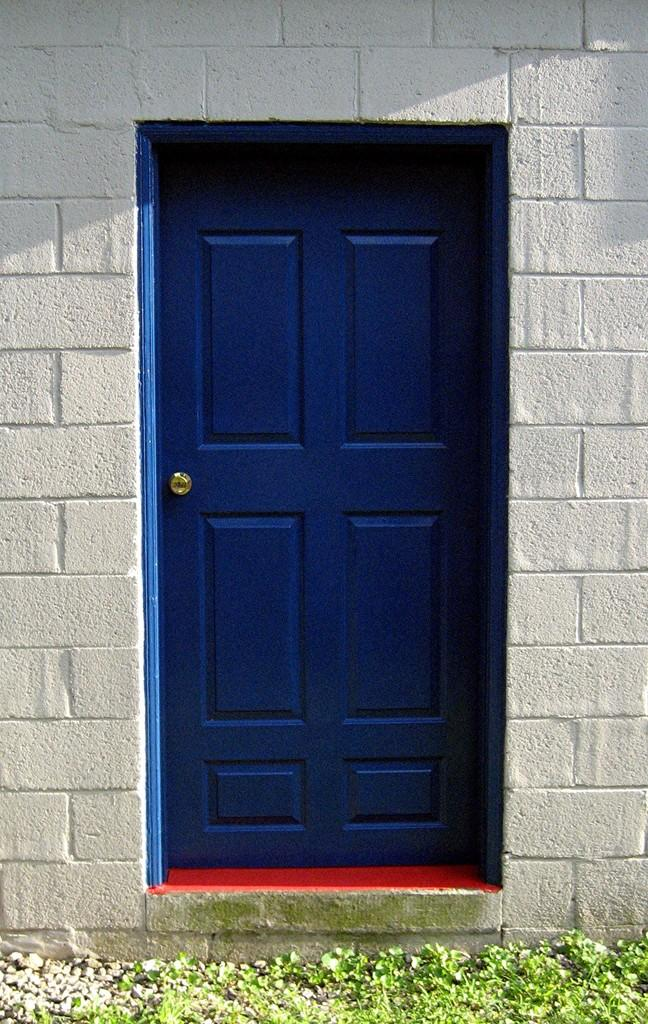What is a prominent feature in the image? There is a door in the image. Where is the door located? The door is in a wall. What can be seen below the door in the image? There is a ground visible in the image. What type of pin can be seen holding up a joke in the image? There is no pin or joke present in the image; it only features a door in a wall and the visible ground. 